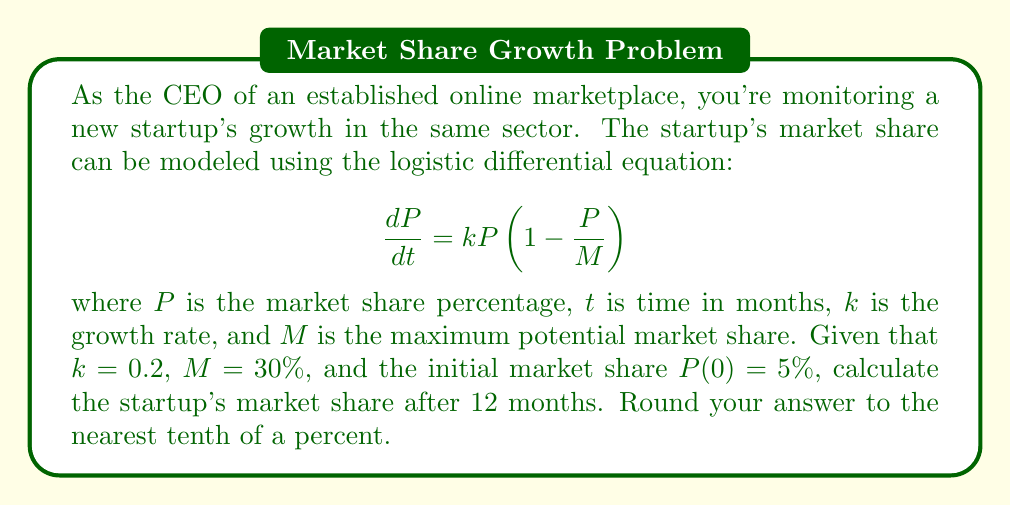Help me with this question. To solve this problem, we need to use the solution to the logistic differential equation:

$$P(t) = \frac{MP_0e^{kt}}{M + P_0(e^{kt} - 1)}$$

where $P_0$ is the initial market share.

Given:
- $k = 0.2$
- $M = 30\%$
- $P_0 = 5\%$
- $t = 12$ months

Let's substitute these values into the equation:

$$P(12) = \frac{30 \cdot 5e^{0.2 \cdot 12}}{30 + 5(e^{0.2 \cdot 12} - 1)}$$

Now, let's solve this step-by-step:

1) First, calculate $e^{0.2 \cdot 12}$:
   $e^{0.2 \cdot 12} = e^{2.4} \approx 11.0232$

2) Substitute this value:
   $$P(12) = \frac{30 \cdot 5 \cdot 11.0232}{30 + 5(11.0232 - 1)}$$

3) Simplify:
   $$P(12) = \frac{1653.48}{30 + 5(10.0232)}$$
   $$P(12) = \frac{1653.48}{30 + 50.116}$$
   $$P(12) = \frac{1653.48}{80.116}$$

4) Calculate the final result:
   $$P(12) \approx 20.6384\%$$

5) Rounding to the nearest tenth of a percent:
   $$P(12) \approx 20.6\%$$
Answer: 20.6% 